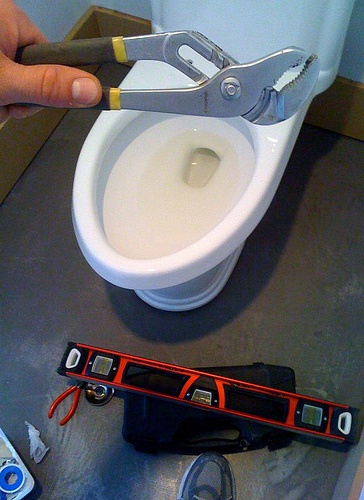Describe the objects in this image and their specific colors. I can see toilet in salmon, lightgray, darkgray, and lightblue tones and people in salmon, brown, and maroon tones in this image. 